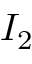Convert formula to latex. <formula><loc_0><loc_0><loc_500><loc_500>I _ { 2 }</formula> 